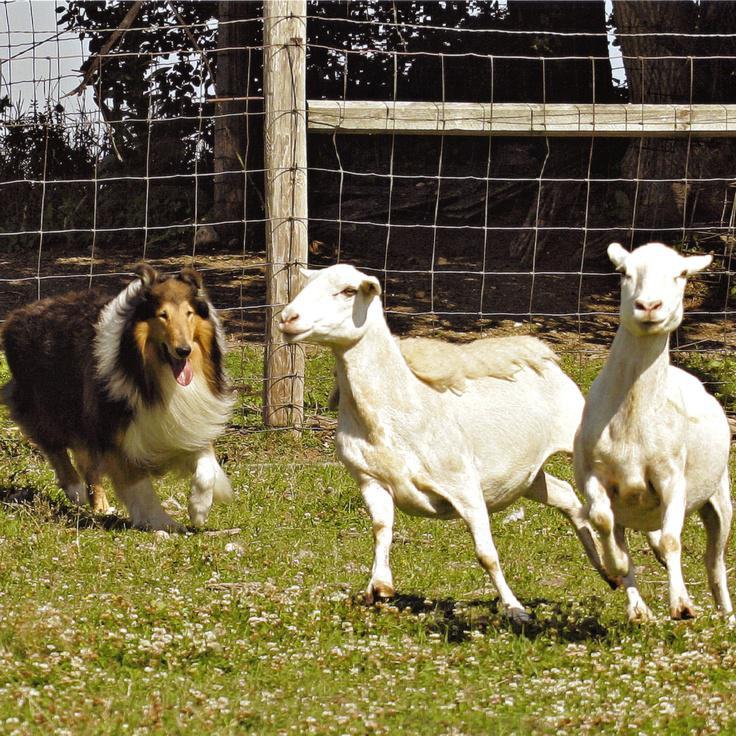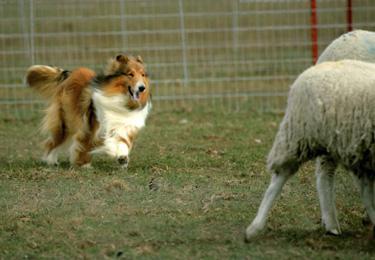The first image is the image on the left, the second image is the image on the right. Considering the images on both sides, is "The right image contains a dog chasing sheep towards the right." valid? Answer yes or no. Yes. The first image is the image on the left, the second image is the image on the right. Analyze the images presented: Is the assertion "An image features a person standing in front of a plank fence and behind multiple sheep, with a dog nearby." valid? Answer yes or no. No. 